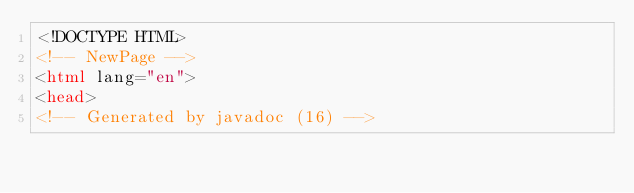<code> <loc_0><loc_0><loc_500><loc_500><_HTML_><!DOCTYPE HTML>
<!-- NewPage -->
<html lang="en">
<head>
<!-- Generated by javadoc (16) --></code> 